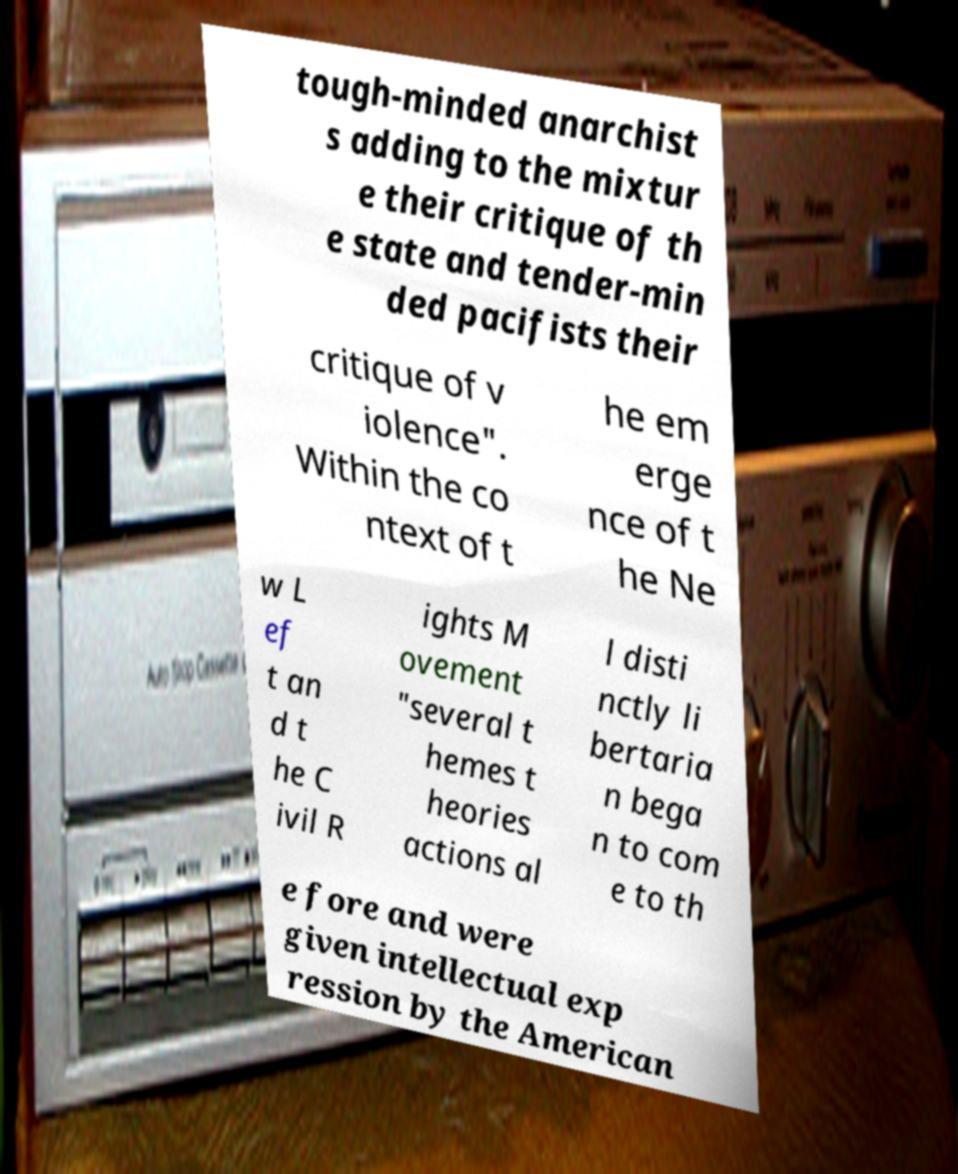There's text embedded in this image that I need extracted. Can you transcribe it verbatim? tough-minded anarchist s adding to the mixtur e their critique of th e state and tender-min ded pacifists their critique of v iolence". Within the co ntext of t he em erge nce of t he Ne w L ef t an d t he C ivil R ights M ovement "several t hemes t heories actions al l disti nctly li bertaria n bega n to com e to th e fore and were given intellectual exp ression by the American 